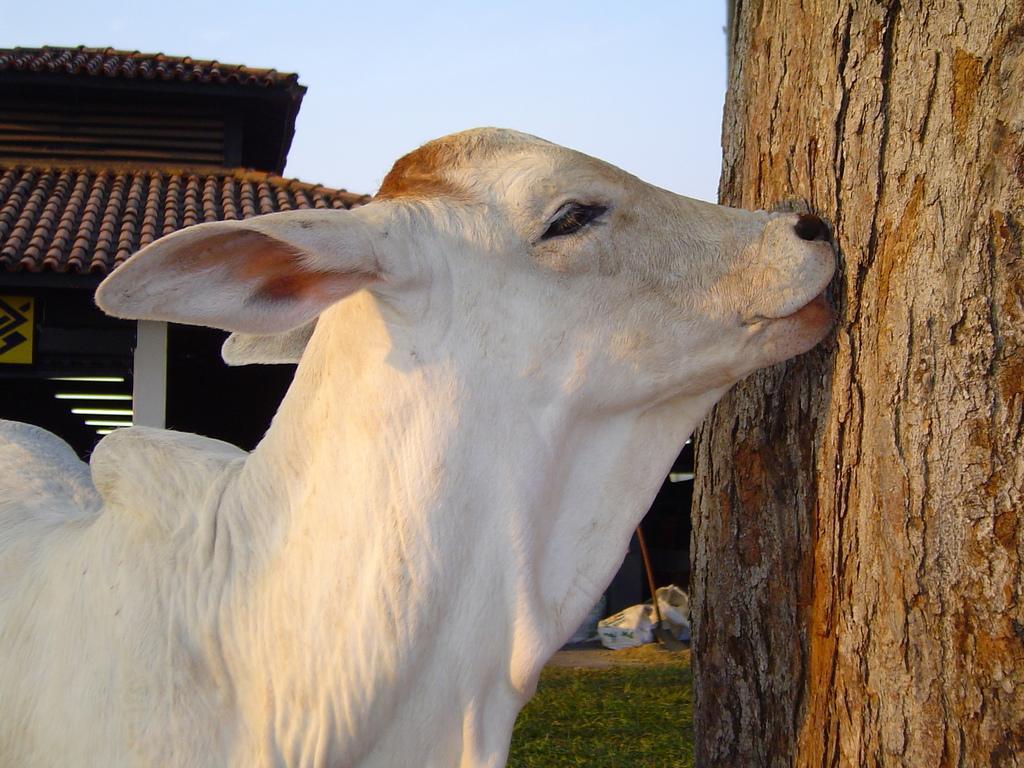Please provide a concise description of this image. In this image I can see an animal. There is a tree trunk. In the top left corner it looks like a shelter. There are some other objects and in the background there is sky. 